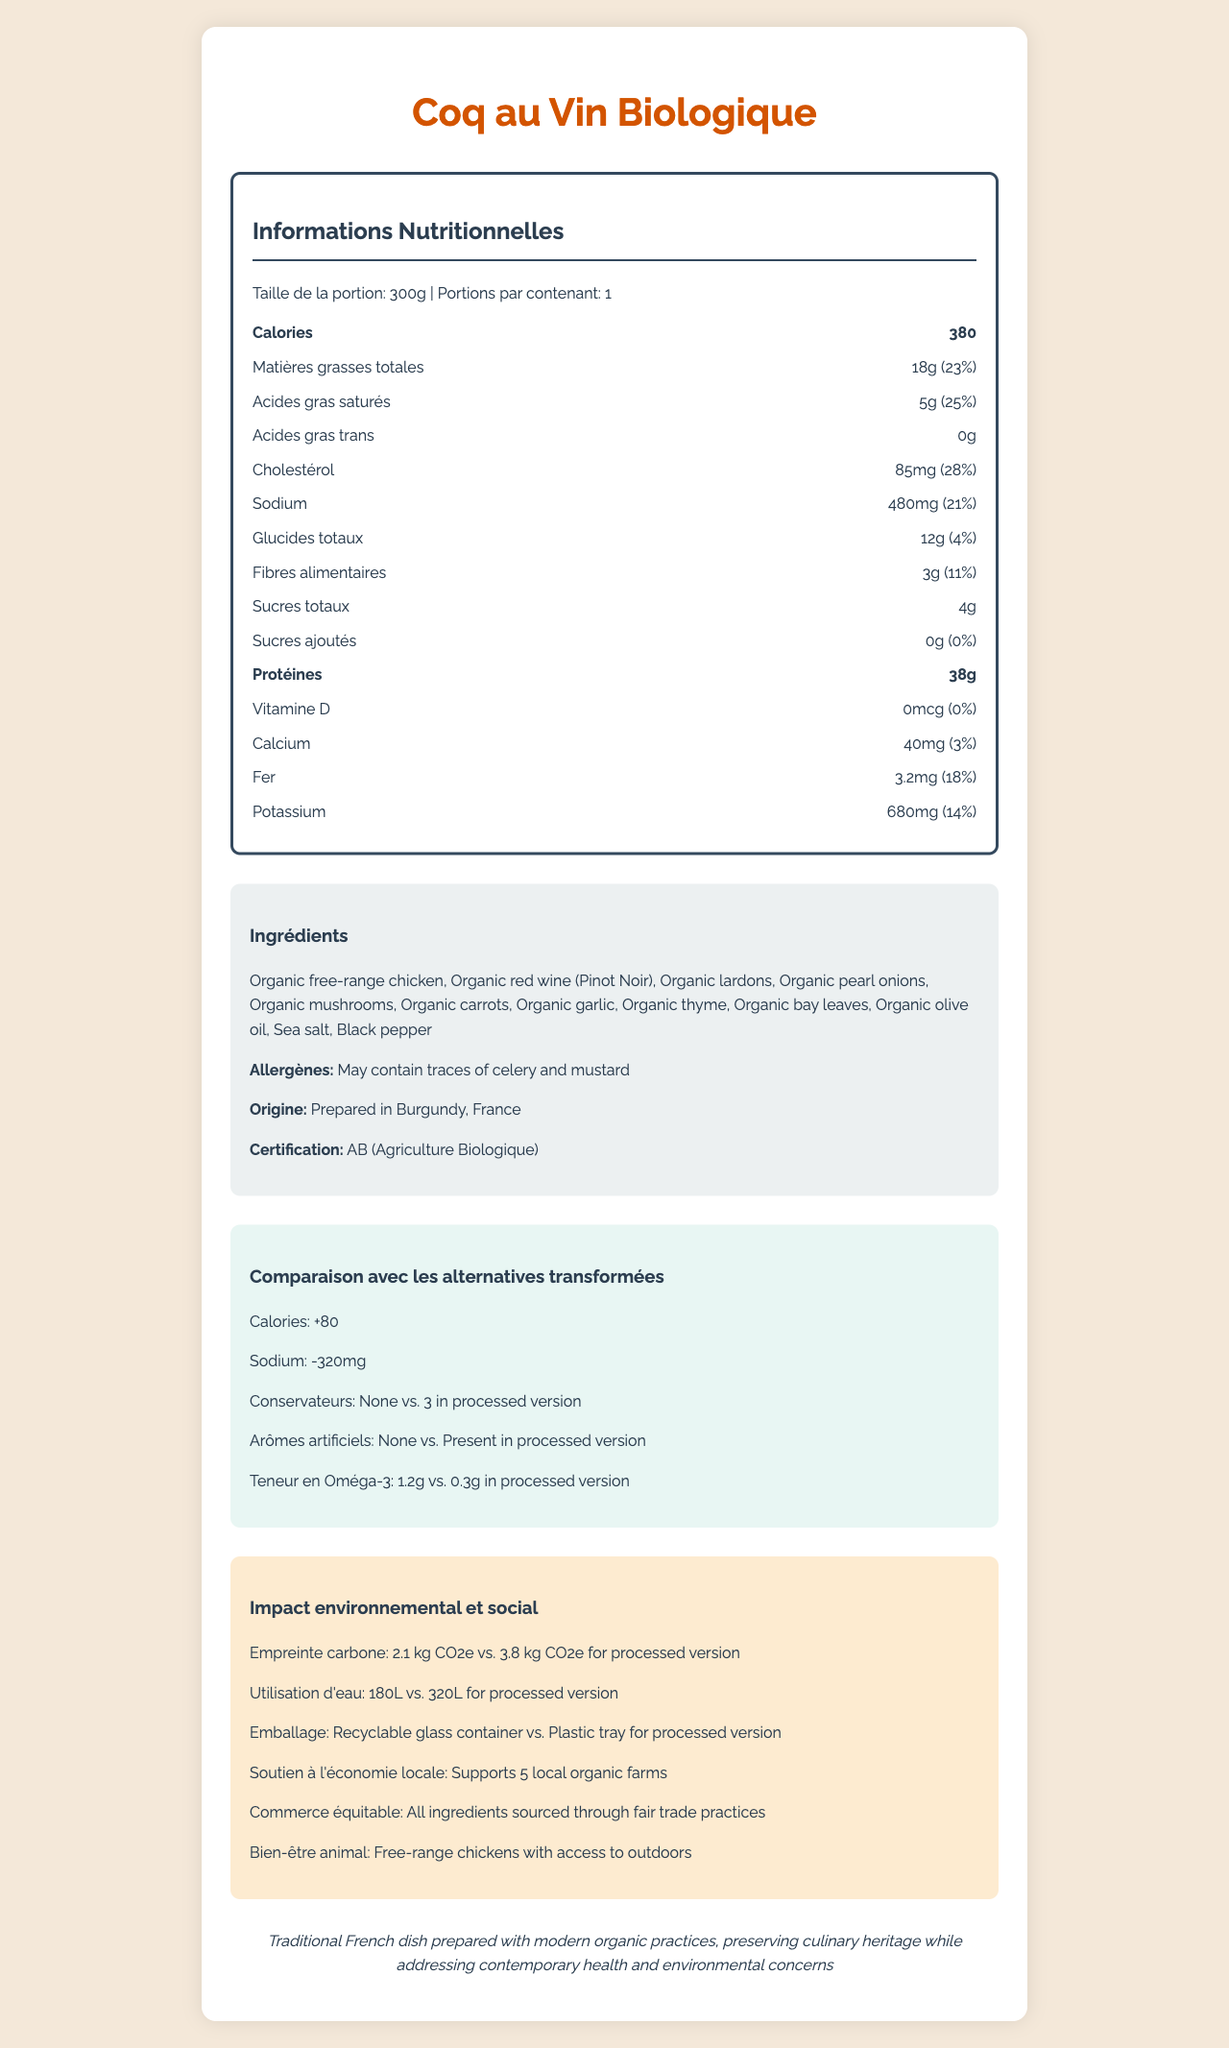what is the serving size? The serving size of the product is listed as "300g" in the nutrition facts section of the document.
Answer: 300g how much sodium is in one serving? The document states that one serving of the product contains 480mg of sodium in the nutrition information section.
Answer: 480mg what is the daily value percentage of saturated fat? The daily value percentage of saturated fat is shown as "25%" in the nutrition facts part.
Answer: 25% how many calories does the Coq au Vin Biologique provide? The calories provided by one serving of Coq au Vin Biologique are listed as "380" in the nutrition label.
Answer: 380 list two key environmental impacts mentioned. The environmental impacts section mentions "2.1 kg CO2e" for carbon footprint and "180L" for water usage.
Answer: Carbon Footprint and Water Usage what certification does the product have? The certification section confirms that the product is certified as "AB (Agriculture Biologique)".
Answer: AB (Agriculture Biologique) how many grams of total fat are in the Coq au Vin Biologique? The document states that the product contains "18g" of total fat per serving.
Answer: 18g which ingredient is not listed in the Coq au Vin Biologique? A. Organic garlic B. Organic bell pepper C. Organic mushrooms The ingredient list in the document includes organic garlic and organic mushrooms, but not organic bell pepper.
Answer: B. Organic bell pepper how much protein is provided per serving? A. 25g B. 30g C. 38g The nutrition label mentions "38g" of protein per serving, making option C the correct choice.
Answer: C. 38g is the product supportive of the local economy? The impact section states that the product "supports 5 local organic farms," indicating economic support.
Answer: Yes does the product contain any artificial flavors? The comparison section notes "None" for artificial flavors in the organic product.
Answer: No is the sodium content higher in the processed version? The comparison section indicates a sodium difference of "-320mg," suggesting higher sodium content in the processed alternative.
Answer: Yes what is the impact on animal welfare according to the document? The social impact section highlights that the product uses free-range chickens with outdoor access.
Answer: Free-range chickens with access to outdoors describe the main idea of the document. The document summarizes the nutritional content, ingredients, certifications, environmental and social impacts, and comparison with processed foods, emphasizing the health, environmental, and cultural advantages of choosing an organic option.
Answer: The document provides detailed nutritional information for Coq au Vin Biologique, a locally-sourced organic meal, comparing its benefits and environmental impacts to processed alternatives. how much potassium does one serving provide? The potassium content per serving is listed as "680mg" in the nutritional information section.
Answer: 680mg what is the exact carbon footprint of the processed version? The document only states the carbon footprint of the Coq au Vin Biologique (2.1 kg CO2e) and mentions that the processed version has a higher footprint (3.8 kg CO2e), but not the exact value.
Answer: Not enough information 